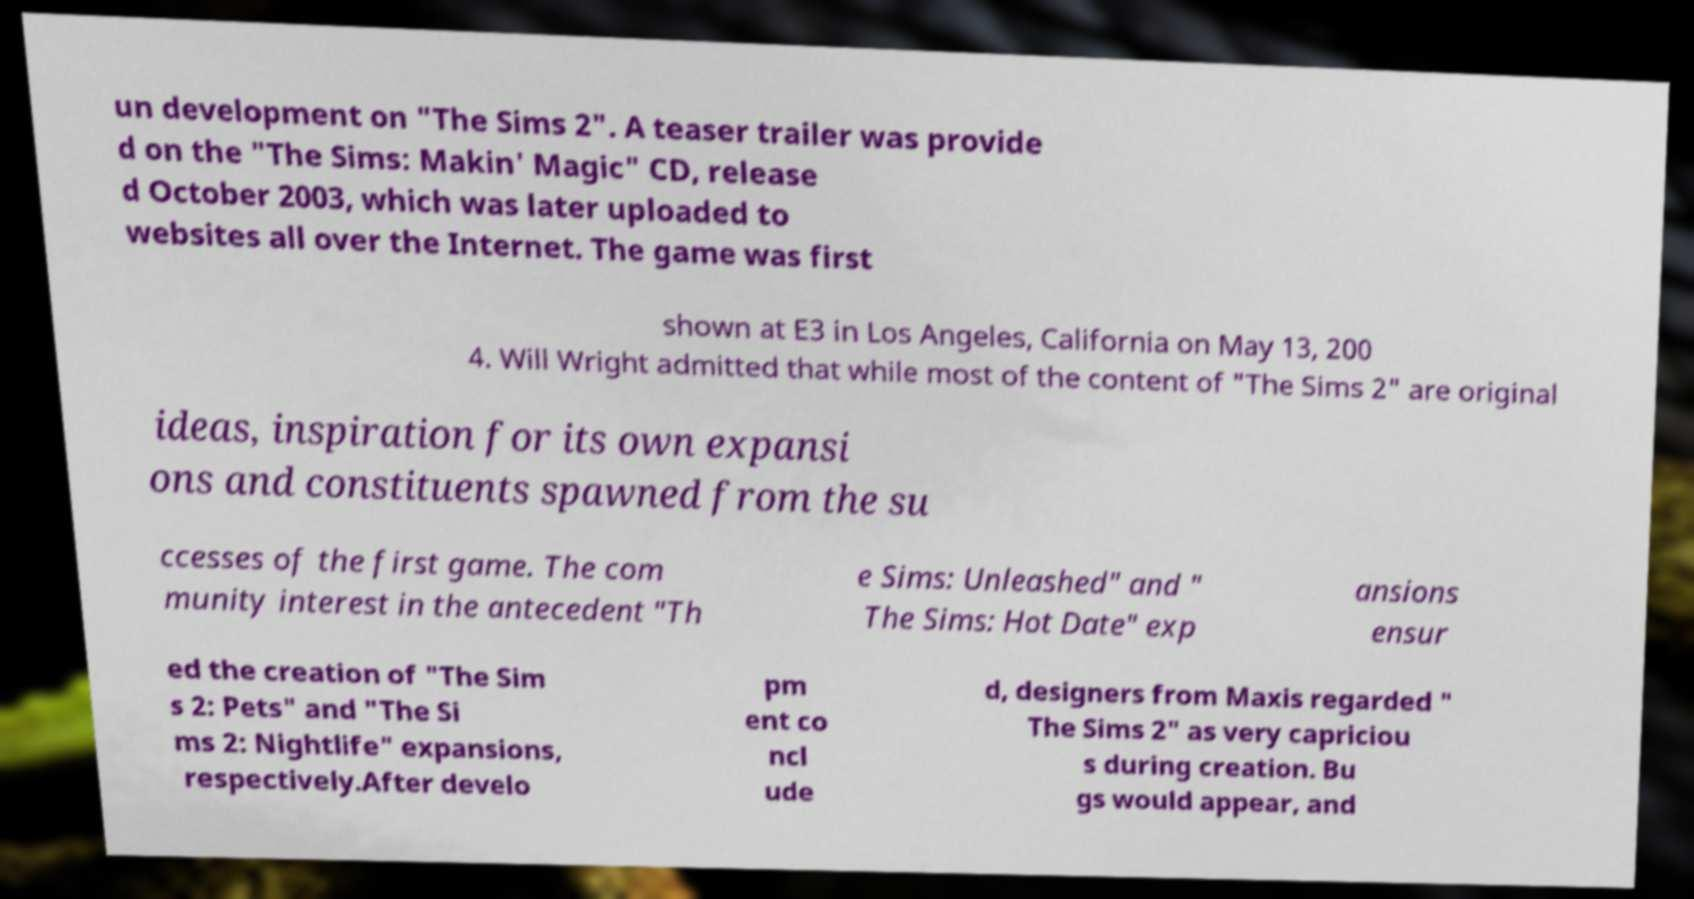What messages or text are displayed in this image? I need them in a readable, typed format. un development on "The Sims 2". A teaser trailer was provide d on the "The Sims: Makin' Magic" CD, release d October 2003, which was later uploaded to websites all over the Internet. The game was first shown at E3 in Los Angeles, California on May 13, 200 4. Will Wright admitted that while most of the content of "The Sims 2" are original ideas, inspiration for its own expansi ons and constituents spawned from the su ccesses of the first game. The com munity interest in the antecedent "Th e Sims: Unleashed" and " The Sims: Hot Date" exp ansions ensur ed the creation of "The Sim s 2: Pets" and "The Si ms 2: Nightlife" expansions, respectively.After develo pm ent co ncl ude d, designers from Maxis regarded " The Sims 2" as very capriciou s during creation. Bu gs would appear, and 